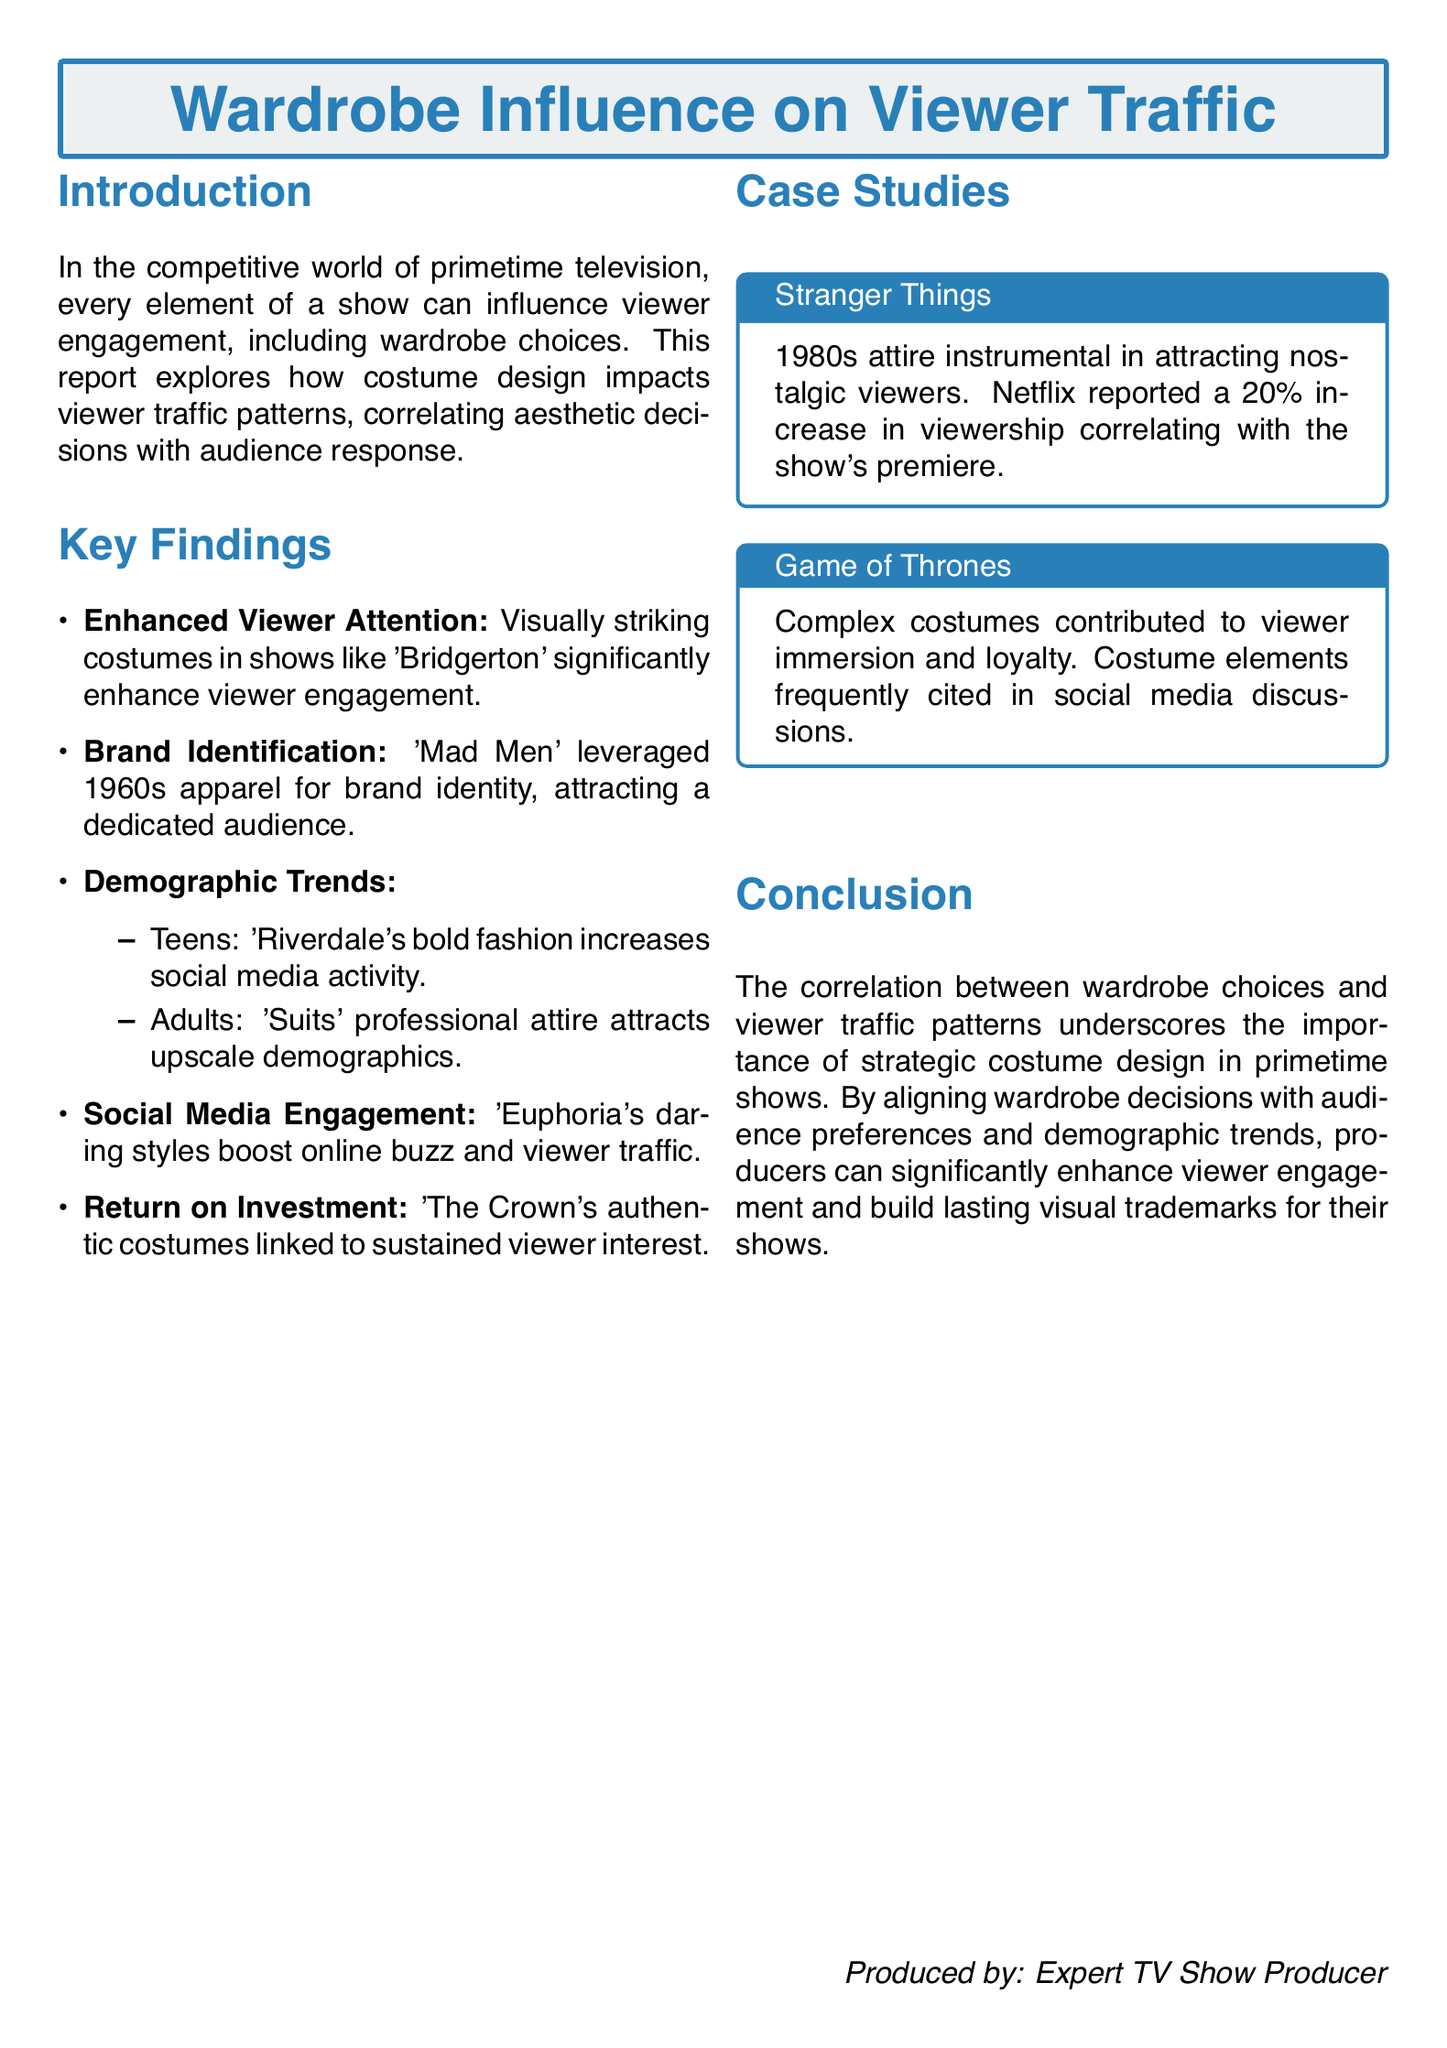What is the main focus of the report? The report focuses on how costume design impacts viewer traffic patterns in primetime television shows.
Answer: Costume design impact on viewer traffic Which show is mentioned as having enhanced viewer attention due to visually striking costumes? The report mentions 'Bridgerton' as an example of a show with visually striking costumes.
Answer: Bridgerton What demographic trend is associated with 'Riverdale'? The report states that 'Riverdale's bold fashion increases social media activity among Teens.
Answer: Teens What percentage increase in viewership did 'Stranger Things' report? The document notes a 20 percent increase in viewership for 'Stranger Things' correlating with its premiere.
Answer: 20 percent Which show's costumes are linked to sustained viewer interest? The report highlights 'The Crown' regarding authentic costumes linking to viewer interest.
Answer: The Crown What decade's attire was instrumental in attracting nostalgic viewers for 'Stranger Things'? The report mentions 1980s attire as the key fashion for 'Stranger Things'.
Answer: 1980s What is highlighted as a factor for brand identification in 'Mad Men'? The document notes that 'Mad Men' leveraged 1960s apparel for brand identity.
Answer: 1960s apparel What aspect of 'Game of Thrones' costumes contributed to viewer loyalty? The report states that complex costumes contributed to viewer immersion and loyalty in 'Game of Thrones'.
Answer: Complex costumes Which show is noted for boosting online buzz with daring styles? The report indicates that 'Euphoria's daring styles lead to increased online buzz and viewer traffic.
Answer: Euphoria 